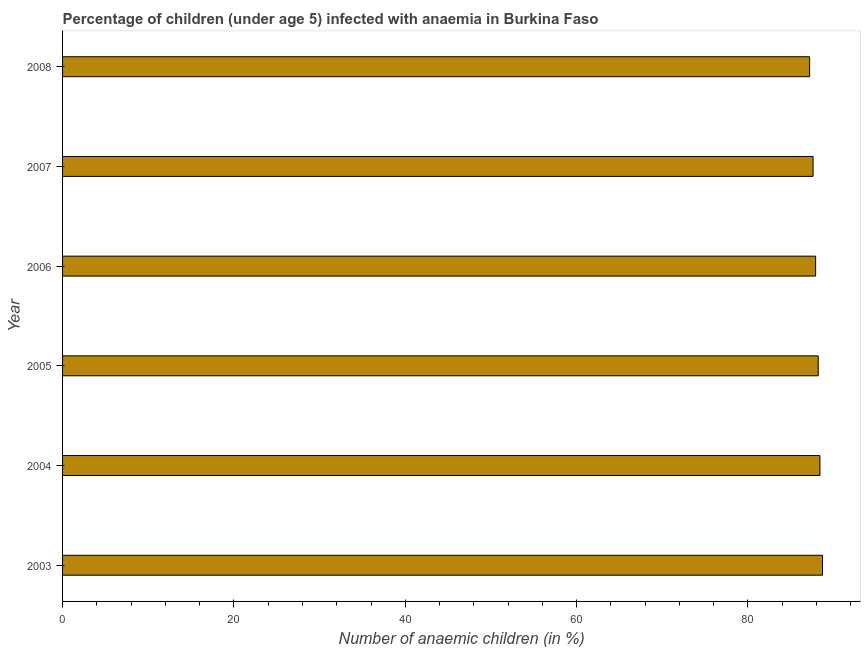What is the title of the graph?
Your response must be concise. Percentage of children (under age 5) infected with anaemia in Burkina Faso. What is the label or title of the X-axis?
Your answer should be compact. Number of anaemic children (in %). What is the label or title of the Y-axis?
Give a very brief answer. Year. What is the number of anaemic children in 2003?
Your answer should be compact. 88.7. Across all years, what is the maximum number of anaemic children?
Provide a succinct answer. 88.7. Across all years, what is the minimum number of anaemic children?
Ensure brevity in your answer.  87.2. What is the sum of the number of anaemic children?
Your response must be concise. 528. What is the average number of anaemic children per year?
Offer a very short reply. 88. What is the median number of anaemic children?
Keep it short and to the point. 88.05. In how many years, is the number of anaemic children greater than 64 %?
Offer a very short reply. 6. What is the ratio of the number of anaemic children in 2006 to that in 2008?
Provide a short and direct response. 1.01. Is the difference between the number of anaemic children in 2004 and 2008 greater than the difference between any two years?
Keep it short and to the point. No. What is the difference between the highest and the second highest number of anaemic children?
Provide a short and direct response. 0.3. How many bars are there?
Provide a succinct answer. 6. How many years are there in the graph?
Offer a terse response. 6. What is the Number of anaemic children (in %) of 2003?
Offer a terse response. 88.7. What is the Number of anaemic children (in %) in 2004?
Give a very brief answer. 88.4. What is the Number of anaemic children (in %) of 2005?
Provide a short and direct response. 88.2. What is the Number of anaemic children (in %) of 2006?
Provide a short and direct response. 87.9. What is the Number of anaemic children (in %) of 2007?
Provide a short and direct response. 87.6. What is the Number of anaemic children (in %) in 2008?
Your answer should be compact. 87.2. What is the difference between the Number of anaemic children (in %) in 2003 and 2005?
Keep it short and to the point. 0.5. What is the difference between the Number of anaemic children (in %) in 2003 and 2006?
Provide a succinct answer. 0.8. What is the difference between the Number of anaemic children (in %) in 2003 and 2007?
Make the answer very short. 1.1. What is the difference between the Number of anaemic children (in %) in 2003 and 2008?
Provide a succinct answer. 1.5. What is the difference between the Number of anaemic children (in %) in 2004 and 2005?
Make the answer very short. 0.2. What is the difference between the Number of anaemic children (in %) in 2004 and 2006?
Make the answer very short. 0.5. What is the difference between the Number of anaemic children (in %) in 2004 and 2007?
Give a very brief answer. 0.8. What is the difference between the Number of anaemic children (in %) in 2005 and 2006?
Your answer should be very brief. 0.3. What is the difference between the Number of anaemic children (in %) in 2005 and 2008?
Give a very brief answer. 1. What is the difference between the Number of anaemic children (in %) in 2006 and 2007?
Keep it short and to the point. 0.3. What is the difference between the Number of anaemic children (in %) in 2007 and 2008?
Provide a succinct answer. 0.4. What is the ratio of the Number of anaemic children (in %) in 2003 to that in 2004?
Ensure brevity in your answer.  1. What is the ratio of the Number of anaemic children (in %) in 2003 to that in 2005?
Your response must be concise. 1.01. What is the ratio of the Number of anaemic children (in %) in 2003 to that in 2006?
Ensure brevity in your answer.  1.01. What is the ratio of the Number of anaemic children (in %) in 2003 to that in 2007?
Your response must be concise. 1.01. What is the ratio of the Number of anaemic children (in %) in 2004 to that in 2005?
Make the answer very short. 1. What is the ratio of the Number of anaemic children (in %) in 2004 to that in 2006?
Provide a short and direct response. 1.01. What is the ratio of the Number of anaemic children (in %) in 2004 to that in 2008?
Make the answer very short. 1.01. What is the ratio of the Number of anaemic children (in %) in 2005 to that in 2007?
Offer a very short reply. 1.01. What is the ratio of the Number of anaemic children (in %) in 2005 to that in 2008?
Offer a terse response. 1.01. What is the ratio of the Number of anaemic children (in %) in 2006 to that in 2008?
Provide a succinct answer. 1.01. 